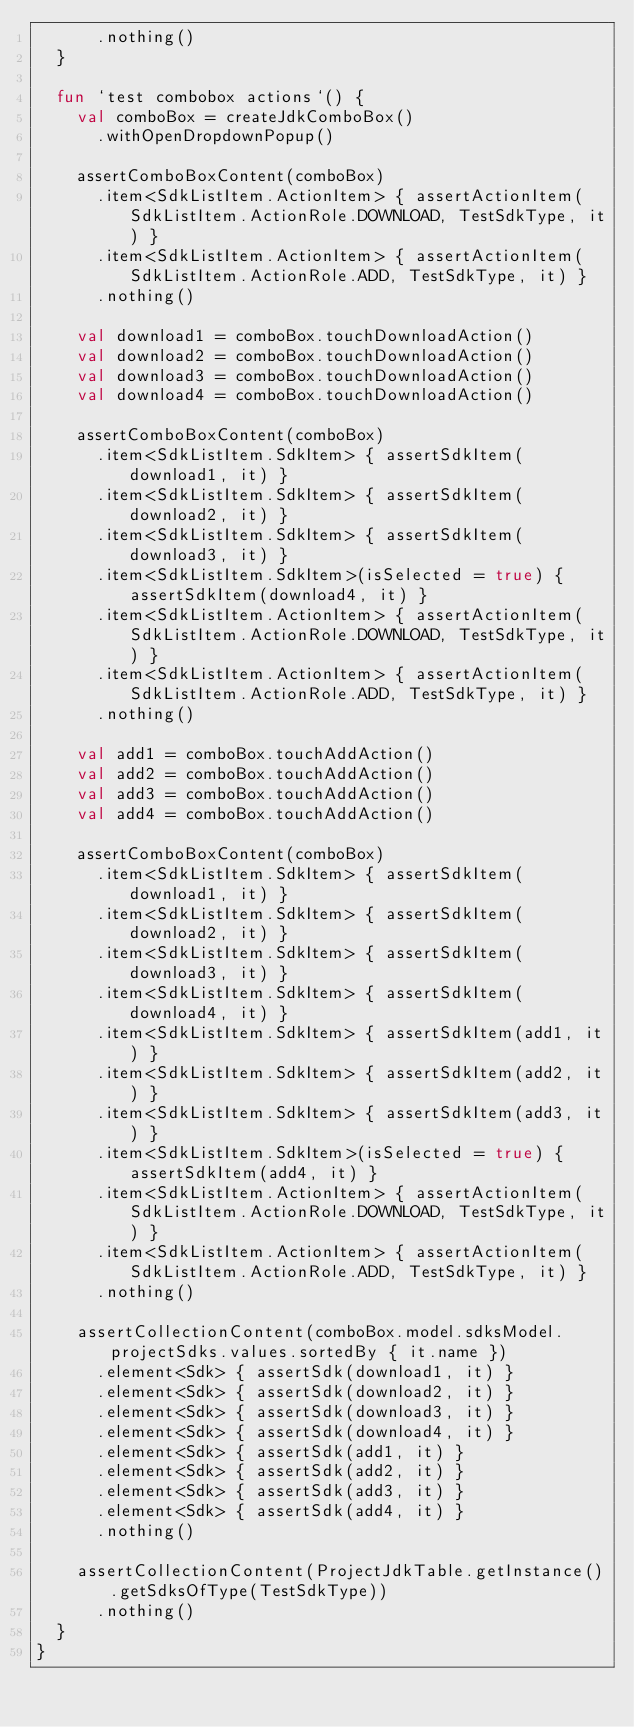<code> <loc_0><loc_0><loc_500><loc_500><_Kotlin_>      .nothing()
  }

  fun `test combobox actions`() {
    val comboBox = createJdkComboBox()
      .withOpenDropdownPopup()

    assertComboBoxContent(comboBox)
      .item<SdkListItem.ActionItem> { assertActionItem(SdkListItem.ActionRole.DOWNLOAD, TestSdkType, it) }
      .item<SdkListItem.ActionItem> { assertActionItem(SdkListItem.ActionRole.ADD, TestSdkType, it) }
      .nothing()

    val download1 = comboBox.touchDownloadAction()
    val download2 = comboBox.touchDownloadAction()
    val download3 = comboBox.touchDownloadAction()
    val download4 = comboBox.touchDownloadAction()

    assertComboBoxContent(comboBox)
      .item<SdkListItem.SdkItem> { assertSdkItem(download1, it) }
      .item<SdkListItem.SdkItem> { assertSdkItem(download2, it) }
      .item<SdkListItem.SdkItem> { assertSdkItem(download3, it) }
      .item<SdkListItem.SdkItem>(isSelected = true) { assertSdkItem(download4, it) }
      .item<SdkListItem.ActionItem> { assertActionItem(SdkListItem.ActionRole.DOWNLOAD, TestSdkType, it) }
      .item<SdkListItem.ActionItem> { assertActionItem(SdkListItem.ActionRole.ADD, TestSdkType, it) }
      .nothing()

    val add1 = comboBox.touchAddAction()
    val add2 = comboBox.touchAddAction()
    val add3 = comboBox.touchAddAction()
    val add4 = comboBox.touchAddAction()

    assertComboBoxContent(comboBox)
      .item<SdkListItem.SdkItem> { assertSdkItem(download1, it) }
      .item<SdkListItem.SdkItem> { assertSdkItem(download2, it) }
      .item<SdkListItem.SdkItem> { assertSdkItem(download3, it) }
      .item<SdkListItem.SdkItem> { assertSdkItem(download4, it) }
      .item<SdkListItem.SdkItem> { assertSdkItem(add1, it) }
      .item<SdkListItem.SdkItem> { assertSdkItem(add2, it) }
      .item<SdkListItem.SdkItem> { assertSdkItem(add3, it) }
      .item<SdkListItem.SdkItem>(isSelected = true) { assertSdkItem(add4, it) }
      .item<SdkListItem.ActionItem> { assertActionItem(SdkListItem.ActionRole.DOWNLOAD, TestSdkType, it) }
      .item<SdkListItem.ActionItem> { assertActionItem(SdkListItem.ActionRole.ADD, TestSdkType, it) }
      .nothing()

    assertCollectionContent(comboBox.model.sdksModel.projectSdks.values.sortedBy { it.name })
      .element<Sdk> { assertSdk(download1, it) }
      .element<Sdk> { assertSdk(download2, it) }
      .element<Sdk> { assertSdk(download3, it) }
      .element<Sdk> { assertSdk(download4, it) }
      .element<Sdk> { assertSdk(add1, it) }
      .element<Sdk> { assertSdk(add2, it) }
      .element<Sdk> { assertSdk(add3, it) }
      .element<Sdk> { assertSdk(add4, it) }
      .nothing()

    assertCollectionContent(ProjectJdkTable.getInstance().getSdksOfType(TestSdkType))
      .nothing()
  }
}</code> 